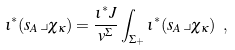<formula> <loc_0><loc_0><loc_500><loc_500>\iota ^ { \ast } ( s _ { A } \lrcorner \chi _ { \kappa } ) = \frac { \iota ^ { \ast } J } { v ^ { \Sigma } } \int _ { \Sigma _ { + } } \iota ^ { \ast } ( s _ { A } \lrcorner \chi _ { \kappa } ) \ ,</formula> 